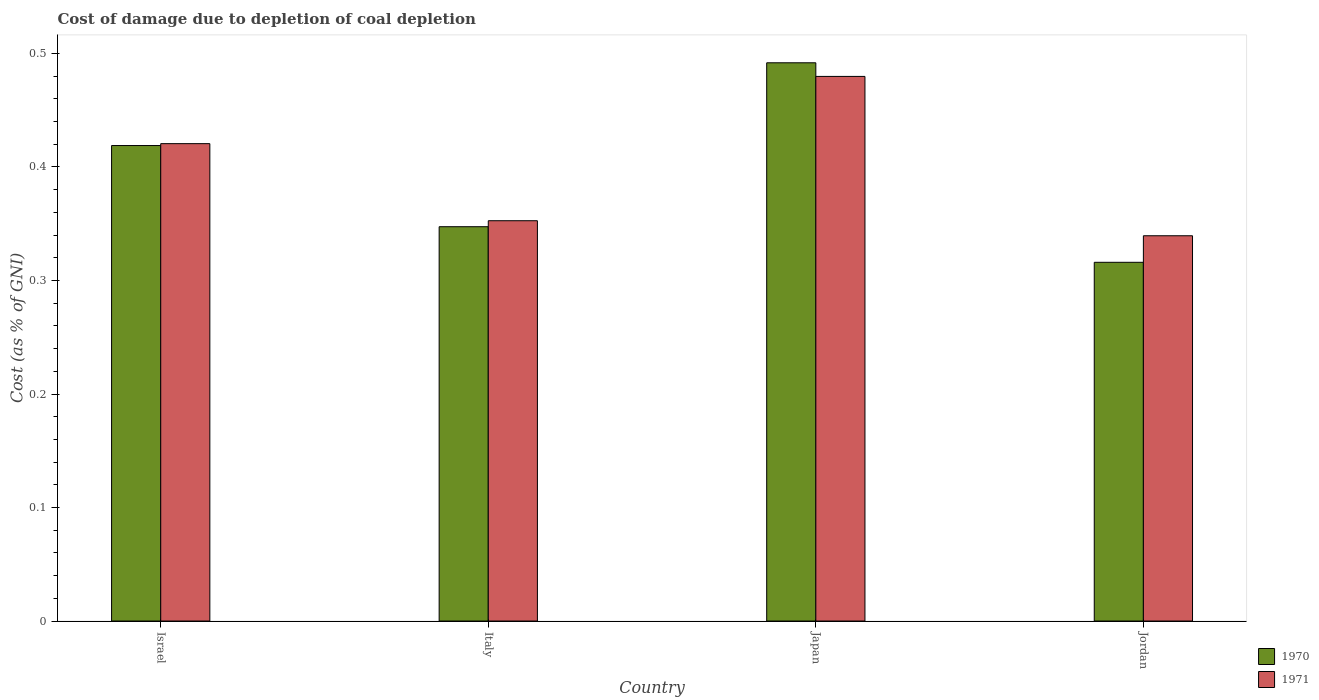How many different coloured bars are there?
Give a very brief answer. 2. How many bars are there on the 1st tick from the left?
Ensure brevity in your answer.  2. What is the cost of damage caused due to coal depletion in 1971 in Italy?
Your answer should be compact. 0.35. Across all countries, what is the maximum cost of damage caused due to coal depletion in 1971?
Your answer should be compact. 0.48. Across all countries, what is the minimum cost of damage caused due to coal depletion in 1970?
Give a very brief answer. 0.32. In which country was the cost of damage caused due to coal depletion in 1971 maximum?
Provide a short and direct response. Japan. In which country was the cost of damage caused due to coal depletion in 1971 minimum?
Ensure brevity in your answer.  Jordan. What is the total cost of damage caused due to coal depletion in 1971 in the graph?
Ensure brevity in your answer.  1.59. What is the difference between the cost of damage caused due to coal depletion in 1971 in Italy and that in Jordan?
Ensure brevity in your answer.  0.01. What is the difference between the cost of damage caused due to coal depletion in 1971 in Japan and the cost of damage caused due to coal depletion in 1970 in Jordan?
Provide a short and direct response. 0.16. What is the average cost of damage caused due to coal depletion in 1970 per country?
Your answer should be very brief. 0.39. What is the difference between the cost of damage caused due to coal depletion of/in 1971 and cost of damage caused due to coal depletion of/in 1970 in Japan?
Provide a succinct answer. -0.01. What is the ratio of the cost of damage caused due to coal depletion in 1970 in Israel to that in Japan?
Your response must be concise. 0.85. Is the difference between the cost of damage caused due to coal depletion in 1971 in Italy and Japan greater than the difference between the cost of damage caused due to coal depletion in 1970 in Italy and Japan?
Give a very brief answer. Yes. What is the difference between the highest and the second highest cost of damage caused due to coal depletion in 1970?
Your answer should be compact. 0.14. What is the difference between the highest and the lowest cost of damage caused due to coal depletion in 1971?
Offer a terse response. 0.14. In how many countries, is the cost of damage caused due to coal depletion in 1971 greater than the average cost of damage caused due to coal depletion in 1971 taken over all countries?
Ensure brevity in your answer.  2. Is the sum of the cost of damage caused due to coal depletion in 1970 in Israel and Italy greater than the maximum cost of damage caused due to coal depletion in 1971 across all countries?
Your response must be concise. Yes. What does the 1st bar from the left in Israel represents?
Make the answer very short. 1970. How many bars are there?
Provide a short and direct response. 8. What is the difference between two consecutive major ticks on the Y-axis?
Your answer should be compact. 0.1. Are the values on the major ticks of Y-axis written in scientific E-notation?
Offer a very short reply. No. Does the graph contain any zero values?
Your answer should be compact. No. Does the graph contain grids?
Offer a terse response. No. Where does the legend appear in the graph?
Offer a very short reply. Bottom right. How are the legend labels stacked?
Keep it short and to the point. Vertical. What is the title of the graph?
Offer a very short reply. Cost of damage due to depletion of coal depletion. What is the label or title of the X-axis?
Offer a very short reply. Country. What is the label or title of the Y-axis?
Make the answer very short. Cost (as % of GNI). What is the Cost (as % of GNI) in 1970 in Israel?
Your answer should be very brief. 0.42. What is the Cost (as % of GNI) in 1971 in Israel?
Provide a short and direct response. 0.42. What is the Cost (as % of GNI) in 1970 in Italy?
Keep it short and to the point. 0.35. What is the Cost (as % of GNI) of 1971 in Italy?
Give a very brief answer. 0.35. What is the Cost (as % of GNI) in 1970 in Japan?
Provide a succinct answer. 0.49. What is the Cost (as % of GNI) of 1971 in Japan?
Give a very brief answer. 0.48. What is the Cost (as % of GNI) of 1970 in Jordan?
Ensure brevity in your answer.  0.32. What is the Cost (as % of GNI) of 1971 in Jordan?
Your response must be concise. 0.34. Across all countries, what is the maximum Cost (as % of GNI) of 1970?
Provide a short and direct response. 0.49. Across all countries, what is the maximum Cost (as % of GNI) of 1971?
Your answer should be compact. 0.48. Across all countries, what is the minimum Cost (as % of GNI) in 1970?
Give a very brief answer. 0.32. Across all countries, what is the minimum Cost (as % of GNI) in 1971?
Offer a very short reply. 0.34. What is the total Cost (as % of GNI) of 1970 in the graph?
Provide a short and direct response. 1.57. What is the total Cost (as % of GNI) of 1971 in the graph?
Your answer should be very brief. 1.59. What is the difference between the Cost (as % of GNI) of 1970 in Israel and that in Italy?
Offer a very short reply. 0.07. What is the difference between the Cost (as % of GNI) of 1971 in Israel and that in Italy?
Provide a succinct answer. 0.07. What is the difference between the Cost (as % of GNI) in 1970 in Israel and that in Japan?
Keep it short and to the point. -0.07. What is the difference between the Cost (as % of GNI) in 1971 in Israel and that in Japan?
Provide a succinct answer. -0.06. What is the difference between the Cost (as % of GNI) of 1970 in Israel and that in Jordan?
Your response must be concise. 0.1. What is the difference between the Cost (as % of GNI) in 1971 in Israel and that in Jordan?
Provide a succinct answer. 0.08. What is the difference between the Cost (as % of GNI) of 1970 in Italy and that in Japan?
Give a very brief answer. -0.14. What is the difference between the Cost (as % of GNI) in 1971 in Italy and that in Japan?
Keep it short and to the point. -0.13. What is the difference between the Cost (as % of GNI) of 1970 in Italy and that in Jordan?
Provide a succinct answer. 0.03. What is the difference between the Cost (as % of GNI) in 1971 in Italy and that in Jordan?
Ensure brevity in your answer.  0.01. What is the difference between the Cost (as % of GNI) of 1970 in Japan and that in Jordan?
Offer a very short reply. 0.18. What is the difference between the Cost (as % of GNI) of 1971 in Japan and that in Jordan?
Provide a succinct answer. 0.14. What is the difference between the Cost (as % of GNI) of 1970 in Israel and the Cost (as % of GNI) of 1971 in Italy?
Make the answer very short. 0.07. What is the difference between the Cost (as % of GNI) of 1970 in Israel and the Cost (as % of GNI) of 1971 in Japan?
Provide a short and direct response. -0.06. What is the difference between the Cost (as % of GNI) in 1970 in Israel and the Cost (as % of GNI) in 1971 in Jordan?
Provide a short and direct response. 0.08. What is the difference between the Cost (as % of GNI) of 1970 in Italy and the Cost (as % of GNI) of 1971 in Japan?
Provide a succinct answer. -0.13. What is the difference between the Cost (as % of GNI) in 1970 in Italy and the Cost (as % of GNI) in 1971 in Jordan?
Keep it short and to the point. 0.01. What is the difference between the Cost (as % of GNI) in 1970 in Japan and the Cost (as % of GNI) in 1971 in Jordan?
Offer a very short reply. 0.15. What is the average Cost (as % of GNI) of 1970 per country?
Provide a short and direct response. 0.39. What is the average Cost (as % of GNI) in 1971 per country?
Offer a very short reply. 0.4. What is the difference between the Cost (as % of GNI) in 1970 and Cost (as % of GNI) in 1971 in Israel?
Make the answer very short. -0. What is the difference between the Cost (as % of GNI) of 1970 and Cost (as % of GNI) of 1971 in Italy?
Offer a very short reply. -0.01. What is the difference between the Cost (as % of GNI) in 1970 and Cost (as % of GNI) in 1971 in Japan?
Give a very brief answer. 0.01. What is the difference between the Cost (as % of GNI) of 1970 and Cost (as % of GNI) of 1971 in Jordan?
Make the answer very short. -0.02. What is the ratio of the Cost (as % of GNI) of 1970 in Israel to that in Italy?
Provide a succinct answer. 1.21. What is the ratio of the Cost (as % of GNI) in 1971 in Israel to that in Italy?
Provide a short and direct response. 1.19. What is the ratio of the Cost (as % of GNI) in 1970 in Israel to that in Japan?
Provide a succinct answer. 0.85. What is the ratio of the Cost (as % of GNI) of 1971 in Israel to that in Japan?
Provide a succinct answer. 0.88. What is the ratio of the Cost (as % of GNI) in 1970 in Israel to that in Jordan?
Provide a short and direct response. 1.33. What is the ratio of the Cost (as % of GNI) in 1971 in Israel to that in Jordan?
Your answer should be compact. 1.24. What is the ratio of the Cost (as % of GNI) in 1970 in Italy to that in Japan?
Keep it short and to the point. 0.71. What is the ratio of the Cost (as % of GNI) of 1971 in Italy to that in Japan?
Offer a terse response. 0.73. What is the ratio of the Cost (as % of GNI) of 1970 in Italy to that in Jordan?
Make the answer very short. 1.1. What is the ratio of the Cost (as % of GNI) in 1971 in Italy to that in Jordan?
Your answer should be very brief. 1.04. What is the ratio of the Cost (as % of GNI) in 1970 in Japan to that in Jordan?
Your answer should be very brief. 1.56. What is the ratio of the Cost (as % of GNI) of 1971 in Japan to that in Jordan?
Provide a succinct answer. 1.41. What is the difference between the highest and the second highest Cost (as % of GNI) in 1970?
Offer a very short reply. 0.07. What is the difference between the highest and the second highest Cost (as % of GNI) of 1971?
Offer a very short reply. 0.06. What is the difference between the highest and the lowest Cost (as % of GNI) in 1970?
Offer a very short reply. 0.18. What is the difference between the highest and the lowest Cost (as % of GNI) of 1971?
Your answer should be compact. 0.14. 